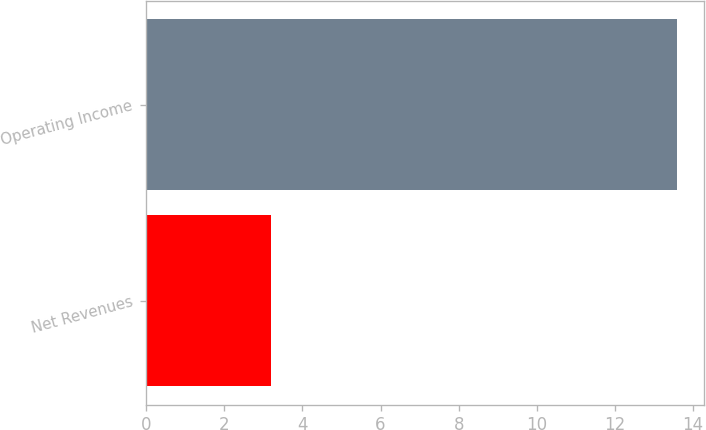Convert chart to OTSL. <chart><loc_0><loc_0><loc_500><loc_500><bar_chart><fcel>Net Revenues<fcel>Operating Income<nl><fcel>3.2<fcel>13.6<nl></chart> 